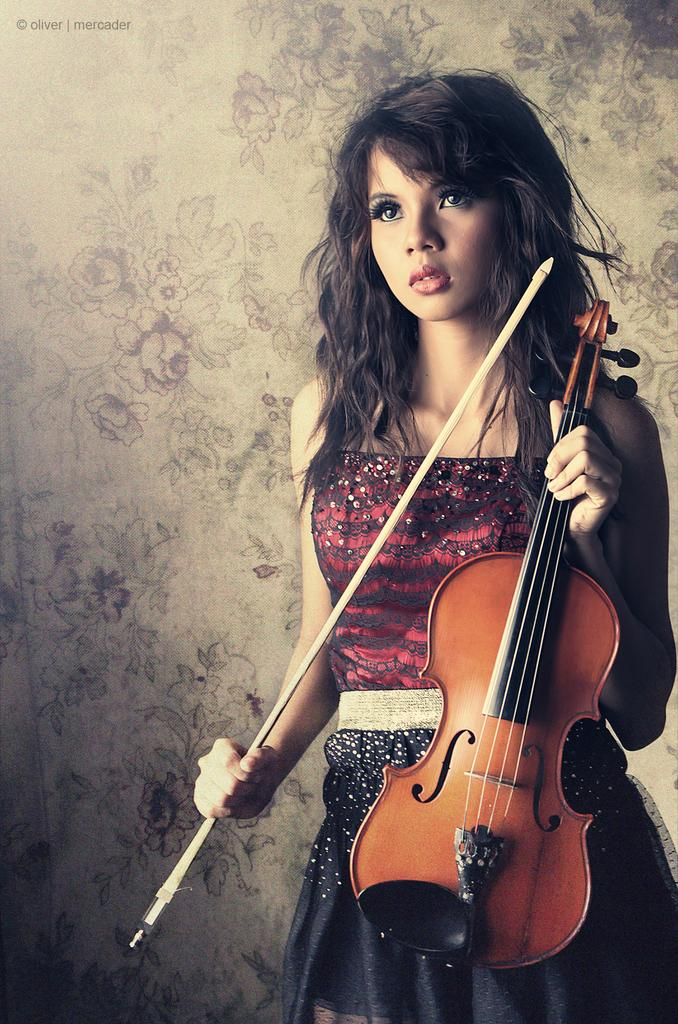Who is the main subject in the image? There is a woman in the image. What is the woman wearing? The woman is wearing a red and black dress. What is the woman holding in the image? The woman is holding a violin with a stick (bow). What type of shade does the woman use to protect herself from the sun in the image? There is no shade present in the image, and the woman is not using any to protect herself from the sun. 